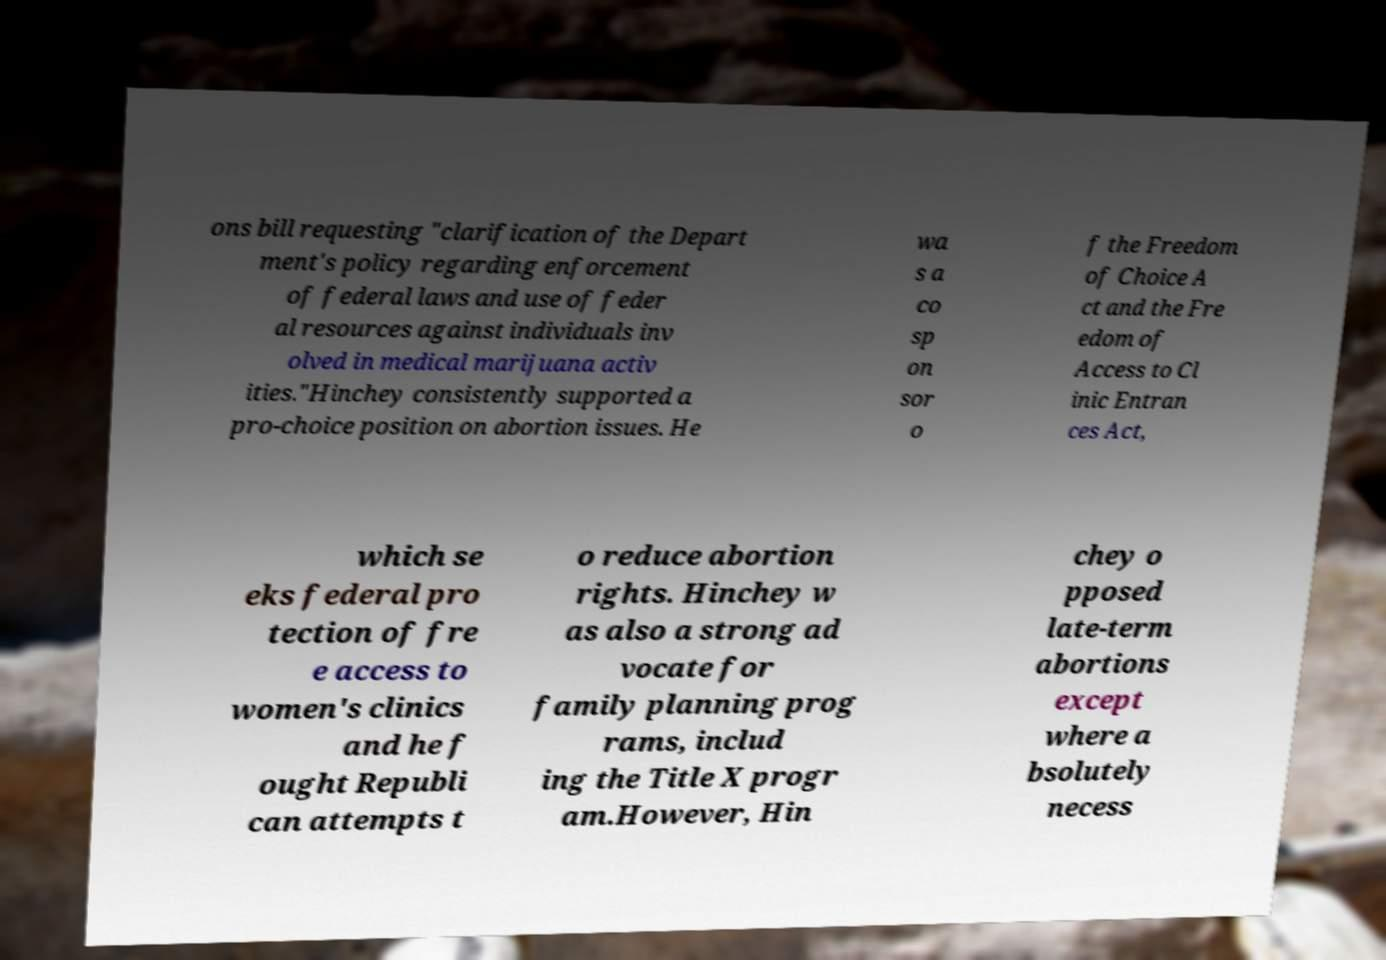Could you assist in decoding the text presented in this image and type it out clearly? ons bill requesting "clarification of the Depart ment's policy regarding enforcement of federal laws and use of feder al resources against individuals inv olved in medical marijuana activ ities."Hinchey consistently supported a pro-choice position on abortion issues. He wa s a co sp on sor o f the Freedom of Choice A ct and the Fre edom of Access to Cl inic Entran ces Act, which se eks federal pro tection of fre e access to women's clinics and he f ought Republi can attempts t o reduce abortion rights. Hinchey w as also a strong ad vocate for family planning prog rams, includ ing the Title X progr am.However, Hin chey o pposed late-term abortions except where a bsolutely necess 